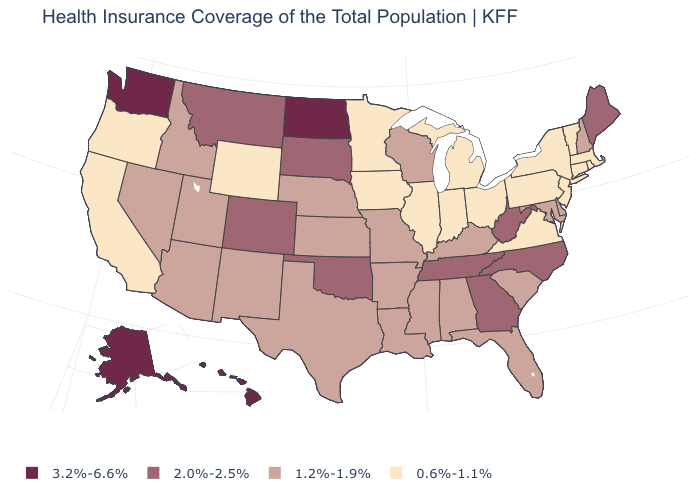Is the legend a continuous bar?
Concise answer only. No. What is the value of New Hampshire?
Give a very brief answer. 1.2%-1.9%. Does California have the lowest value in the West?
Keep it brief. Yes. What is the value of North Dakota?
Give a very brief answer. 3.2%-6.6%. Name the states that have a value in the range 2.0%-2.5%?
Concise answer only. Colorado, Georgia, Maine, Montana, North Carolina, Oklahoma, South Dakota, Tennessee, West Virginia. What is the value of Minnesota?
Answer briefly. 0.6%-1.1%. Which states have the lowest value in the Northeast?
Short answer required. Connecticut, Massachusetts, New Jersey, New York, Pennsylvania, Rhode Island, Vermont. Among the states that border Minnesota , which have the lowest value?
Answer briefly. Iowa. What is the value of Montana?
Quick response, please. 2.0%-2.5%. Does Alabama have the lowest value in the USA?
Short answer required. No. What is the highest value in the USA?
Short answer required. 3.2%-6.6%. Name the states that have a value in the range 3.2%-6.6%?
Answer briefly. Alaska, Hawaii, North Dakota, Washington. Name the states that have a value in the range 0.6%-1.1%?
Quick response, please. California, Connecticut, Illinois, Indiana, Iowa, Massachusetts, Michigan, Minnesota, New Jersey, New York, Ohio, Oregon, Pennsylvania, Rhode Island, Vermont, Virginia, Wyoming. Does Alaska have a higher value than Washington?
Keep it brief. No. Which states have the highest value in the USA?
Give a very brief answer. Alaska, Hawaii, North Dakota, Washington. 